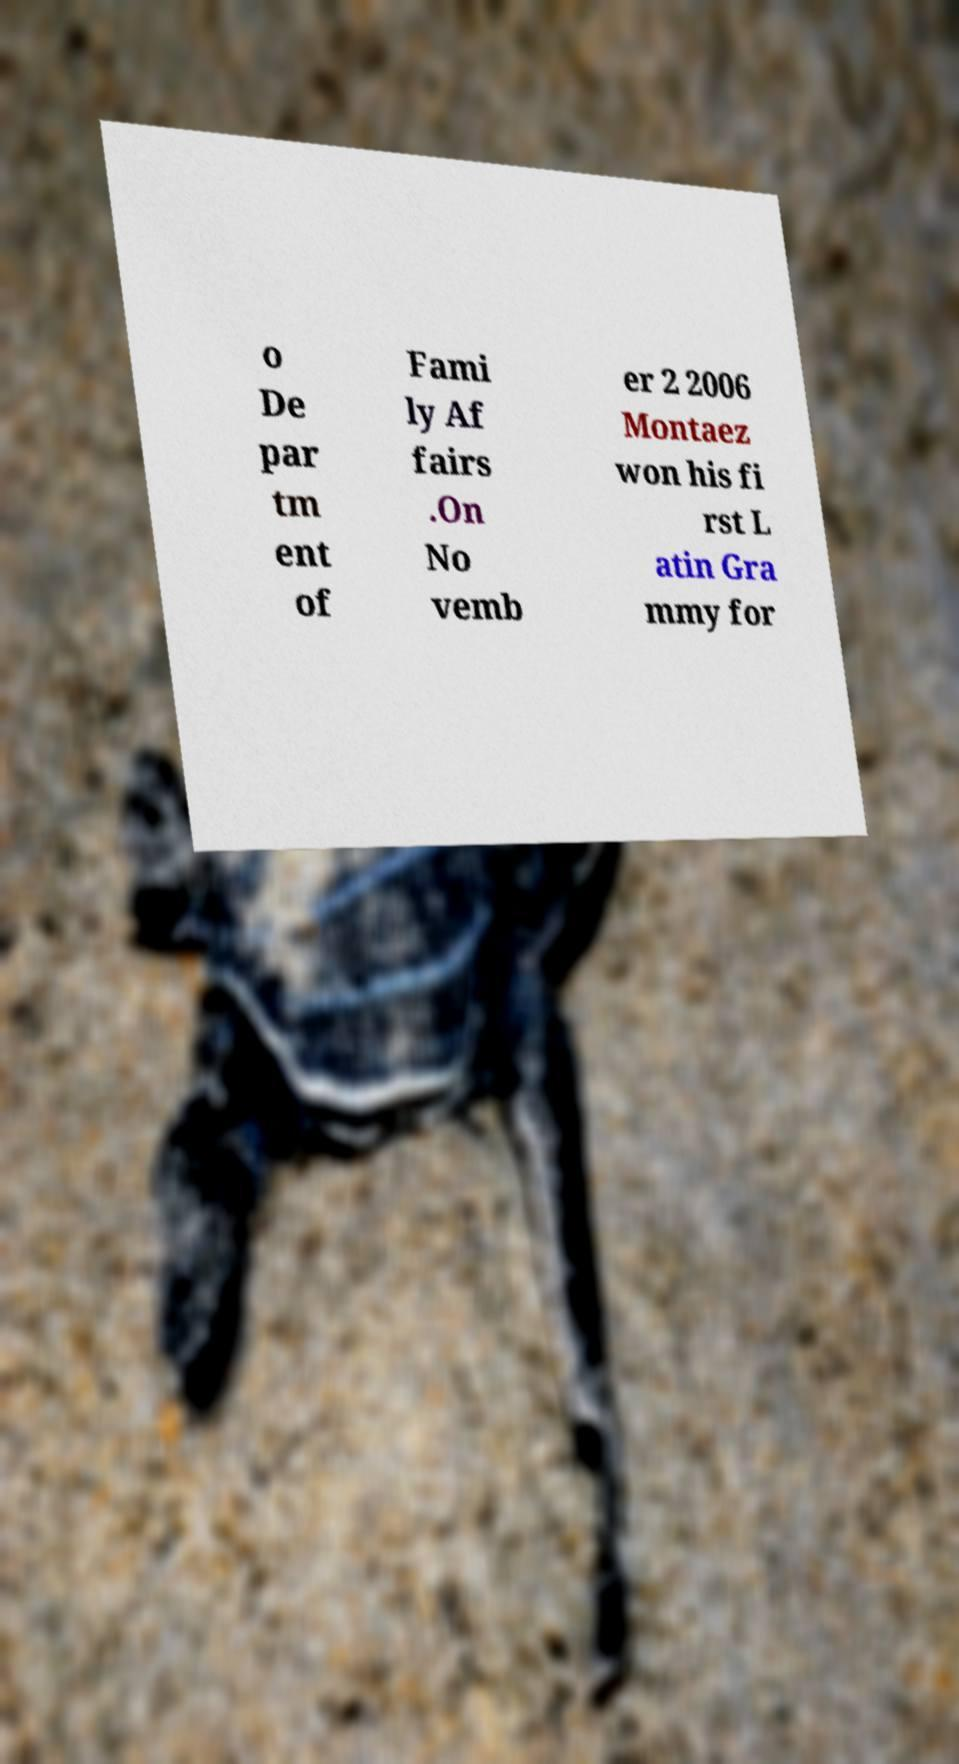For documentation purposes, I need the text within this image transcribed. Could you provide that? o De par tm ent of Fami ly Af fairs .On No vemb er 2 2006 Montaez won his fi rst L atin Gra mmy for 